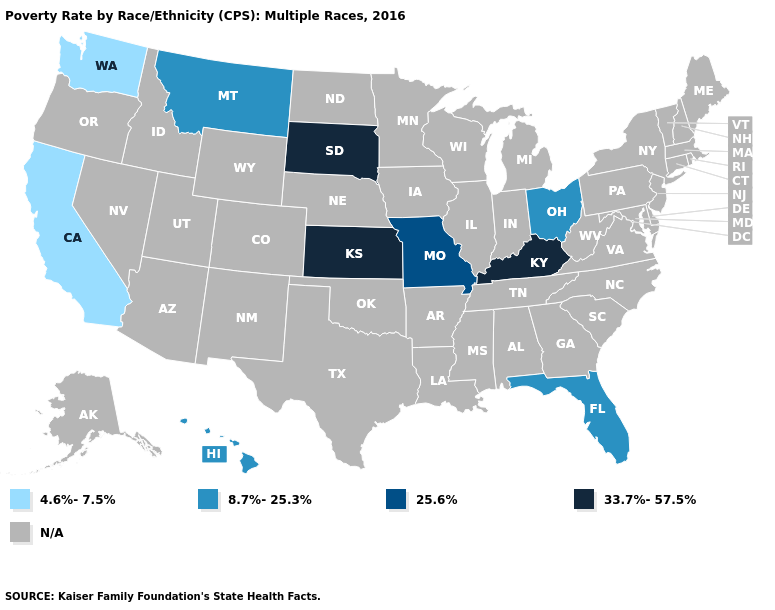Name the states that have a value in the range 4.6%-7.5%?
Answer briefly. California, Washington. Name the states that have a value in the range N/A?
Write a very short answer. Alabama, Alaska, Arizona, Arkansas, Colorado, Connecticut, Delaware, Georgia, Idaho, Illinois, Indiana, Iowa, Louisiana, Maine, Maryland, Massachusetts, Michigan, Minnesota, Mississippi, Nebraska, Nevada, New Hampshire, New Jersey, New Mexico, New York, North Carolina, North Dakota, Oklahoma, Oregon, Pennsylvania, Rhode Island, South Carolina, Tennessee, Texas, Utah, Vermont, Virginia, West Virginia, Wisconsin, Wyoming. Does the map have missing data?
Give a very brief answer. Yes. Does the first symbol in the legend represent the smallest category?
Write a very short answer. Yes. Which states have the lowest value in the USA?
Give a very brief answer. California, Washington. What is the highest value in the South ?
Give a very brief answer. 33.7%-57.5%. What is the lowest value in the South?
Short answer required. 8.7%-25.3%. What is the value of North Dakota?
Answer briefly. N/A. Name the states that have a value in the range 33.7%-57.5%?
Write a very short answer. Kansas, Kentucky, South Dakota. How many symbols are there in the legend?
Quick response, please. 5. What is the value of Pennsylvania?
Write a very short answer. N/A. Which states have the lowest value in the MidWest?
Be succinct. Ohio. Among the states that border Arkansas , which have the lowest value?
Give a very brief answer. Missouri. 